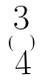Convert formula to latex. <formula><loc_0><loc_0><loc_500><loc_500>( \begin{matrix} 3 \\ 4 \end{matrix} )</formula> 